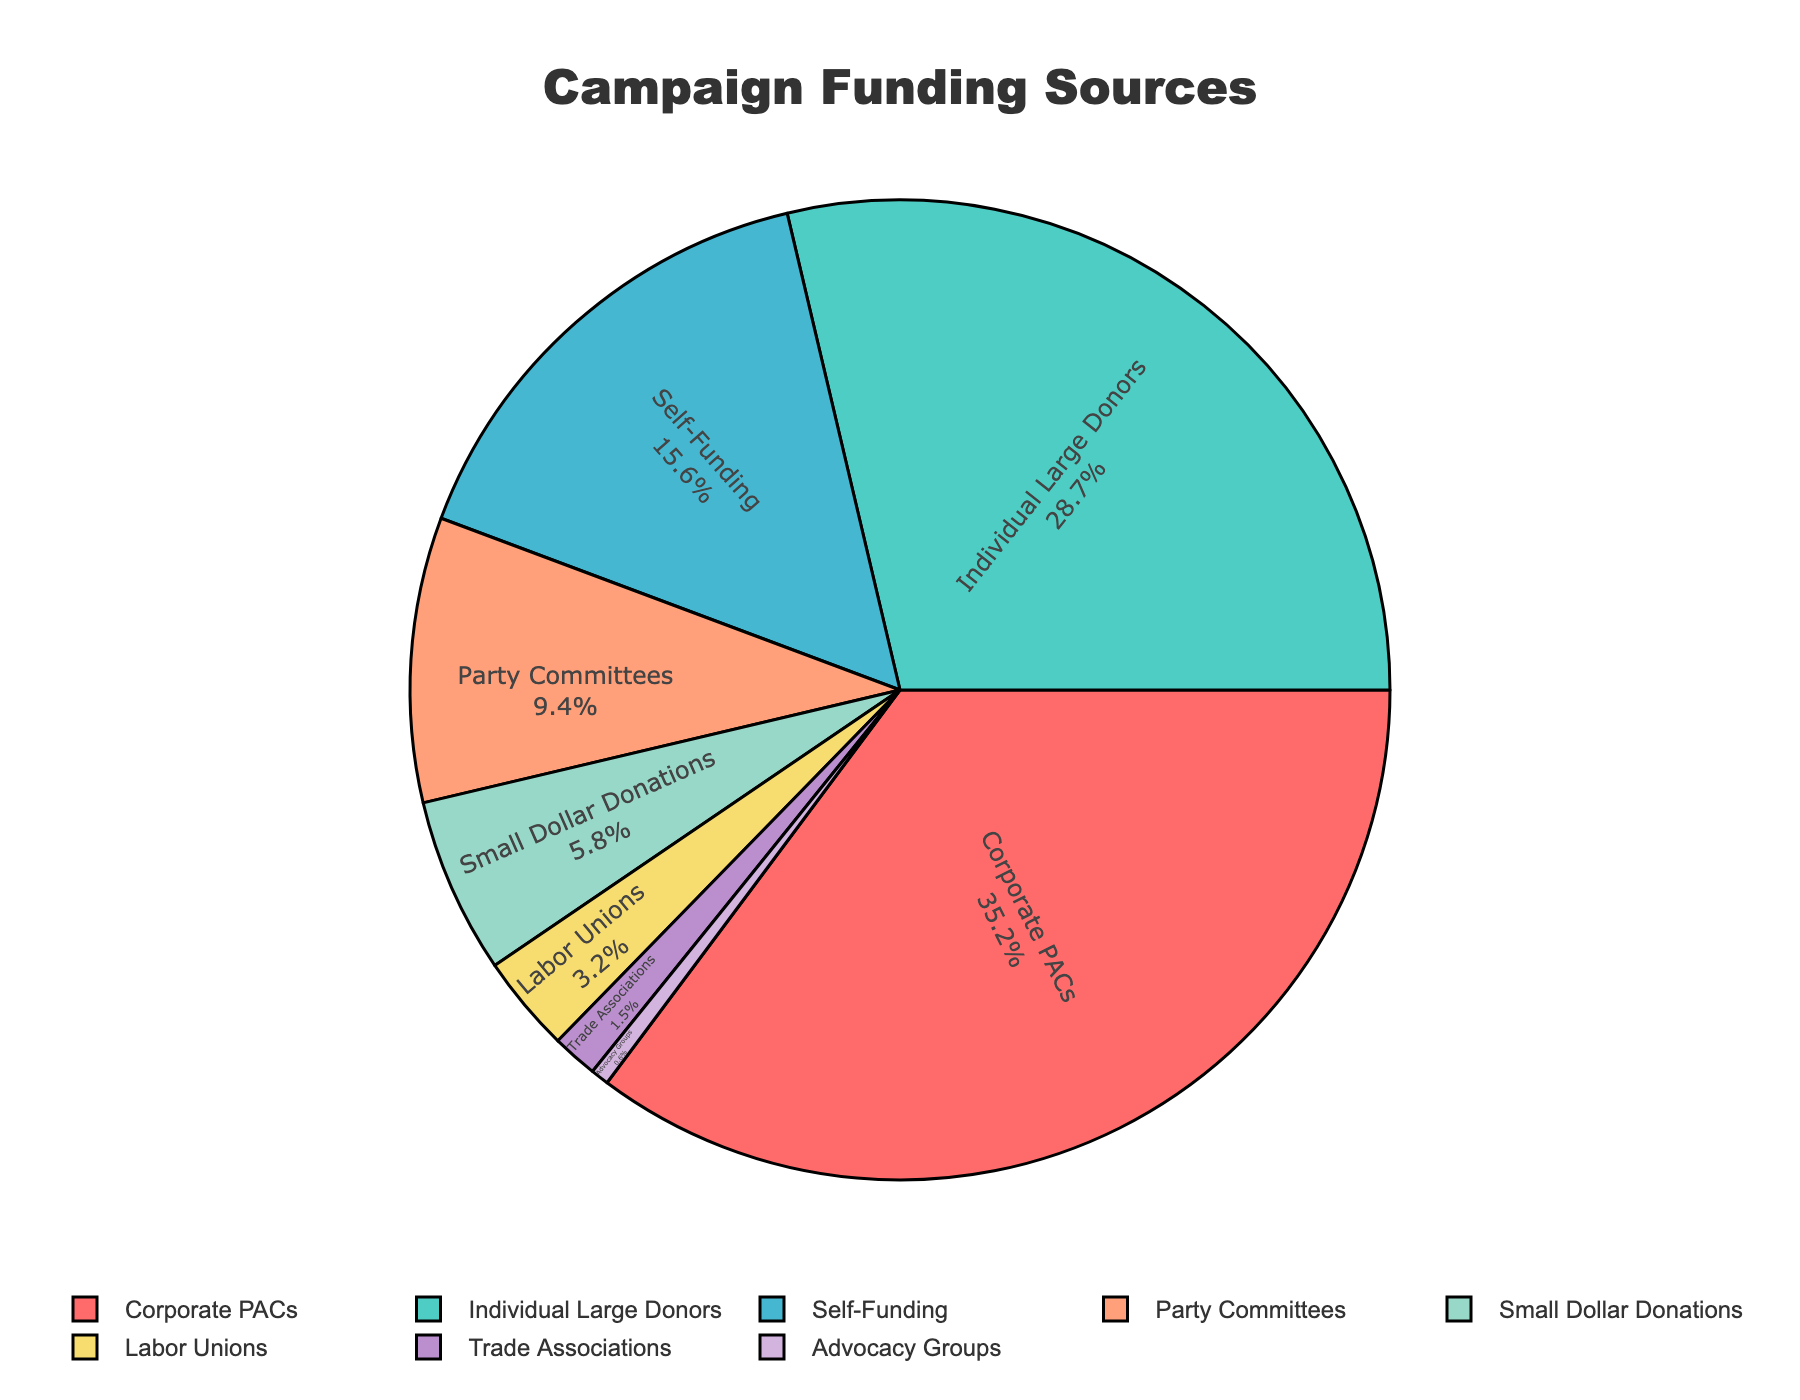What is the largest source of campaign funding? The largest source can be identified by looking for the section of the pie chart with the highest percentage value. Corporate PACs hold the largest portion at 35.2%.
Answer: Corporate PACs Which funding source contributes the least to the campaign? The smallest section of the pie chart represents the funding source with the smallest percentage. Advocacy Groups contribute the least at 0.6%.
Answer: Advocacy Groups What is the combined percentage of funding from Corporate PACs and Individual Large Donors? Add the percentages for Corporate PACs (35.2%) and Individual Large Donors (28.7%). The total is 35.2 + 28.7 = 63.9%.
Answer: 63.9% Which two funding sources together make up approximately 25% of the total funding? Check combinations of sources to see if their total percentages approximate 25%. Combining Self-Funding (15.6%) and Party Committees (9.4%) results in 15.6 + 9.4 = 25%.
Answer: Self-Funding and Party Committees Is the percentage of campaign funding from Labor Unions greater than that from Trade Associations? Compare the slices labeled Labor Unions (3.2%) and Trade Associations (1.5%). Labor Unions have a higher percentage.
Answer: Yes What is the visual color representing Small Dollar Donations, and what is its percentage? Identify the section labeled Small Dollar Donations and check its color. Small Dollar Donations is represented by a yellow color, and its percentage is 5.8%.
Answer: Yellow, 5.8% What is the total percentage of funding from Self-Funding, Labor Unions, and Trade Associations? Sum the percentages for Self-Funding (15.6%), Labor Unions (3.2%), and Trade Associations (1.5%). The total is 15.6 + 3.2 + 1.5 = 20.3%.
Answer: 20.3% Which source has a higher percentage: Small Dollar Donations or Labor Unions? Compare the percentages of Small Dollar Donations (5.8%) and Labor Unions (3.2%). Small Dollar Donations have a higher percentage.
Answer: Small Dollar Donations Combining funding from Party Committees and Labor Unions, is their total contribution greater than that from Self-Funding? Calculate the sum of Party Committees (9.4%) and Labor Unions (3.2%), then compare it to Self-Funding (15.6%). The combined value is 9.4 + 3.2 = 12.6%, which is less than 15.6%.
Answer: No If Advocacy Groups had doubled their contribution, what would their new percentage be? Multiply the original percentage of Advocacy Groups by 2. The new percentage is 0.6% * 2 = 1.2%.
Answer: 1.2% 